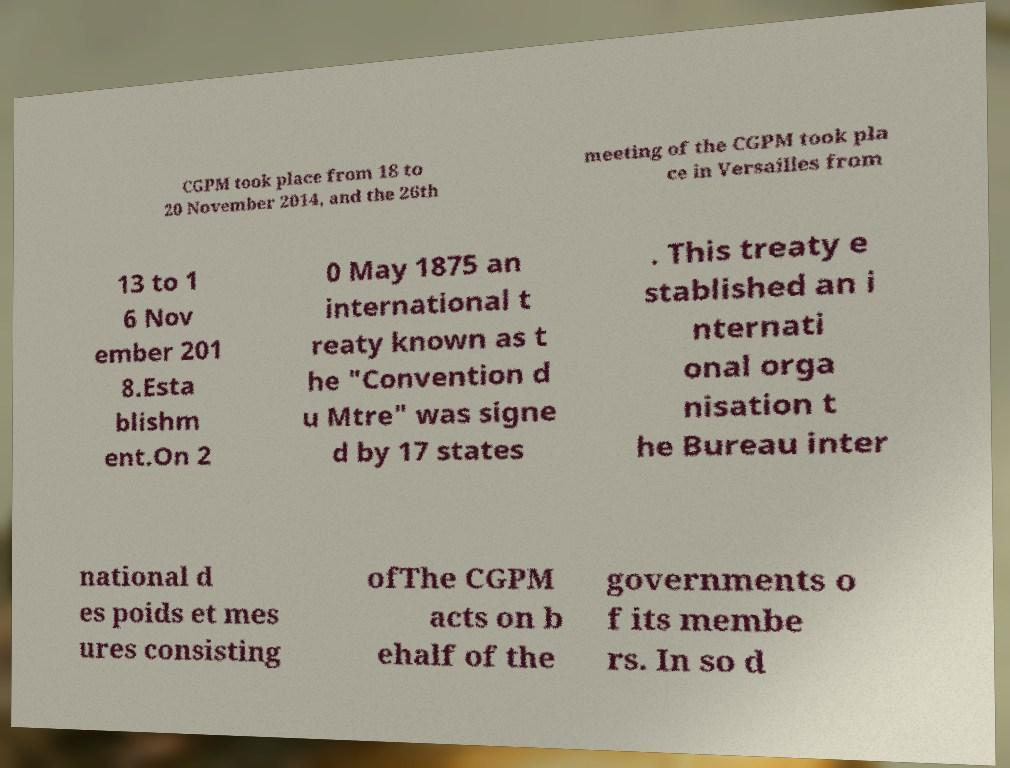There's text embedded in this image that I need extracted. Can you transcribe it verbatim? CGPM took place from 18 to 20 November 2014, and the 26th meeting of the CGPM took pla ce in Versailles from 13 to 1 6 Nov ember 201 8.Esta blishm ent.On 2 0 May 1875 an international t reaty known as t he "Convention d u Mtre" was signe d by 17 states . This treaty e stablished an i nternati onal orga nisation t he Bureau inter national d es poids et mes ures consisting ofThe CGPM acts on b ehalf of the governments o f its membe rs. In so d 